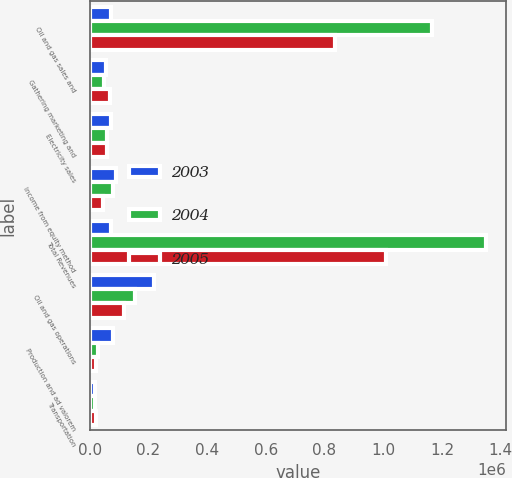Convert chart. <chart><loc_0><loc_0><loc_500><loc_500><stacked_bar_chart><ecel><fcel>Oil and gas sales and<fcel>Gathering marketing and<fcel>Electricity sales<fcel>Income from equity method<fcel>Total Revenues<fcel>Oil and gas operations<fcel>Production and ad valorem<fcel>Transportation<nl><fcel>2003<fcel>71193<fcel>55261<fcel>74228<fcel>90812<fcel>71193<fcel>217860<fcel>78703<fcel>16764<nl><fcel>2004<fcel>1.16498e+06<fcel>49250<fcel>58627<fcel>78199<fcel>1.35105e+06<fcel>153106<fcel>28022<fcel>19808<nl><fcel>2005<fcel>836860<fcel>68158<fcel>58022<fcel>45186<fcel>1.00823e+06<fcel>118027<fcel>22722<fcel>20888<nl></chart> 